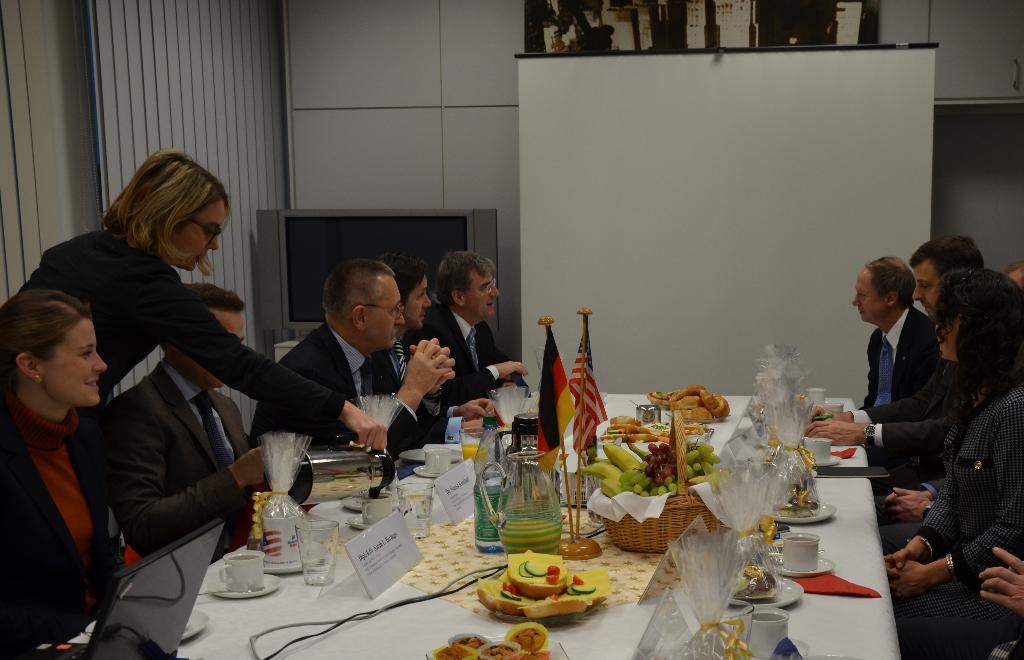Please provide a concise description of this image. In the image we can see there are people who are sitting on chair and on table there is basket in which there are fruits, there are small flags, there is juice jug, there are name plates, there are gifts in which there are glasses, cup, mug. 